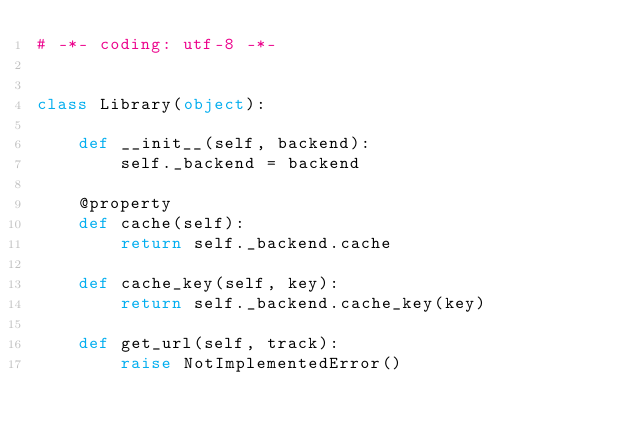Convert code to text. <code><loc_0><loc_0><loc_500><loc_500><_Python_># -*- coding: utf-8 -*-


class Library(object):

    def __init__(self, backend):
        self._backend = backend

    @property
    def cache(self):
        return self._backend.cache

    def cache_key(self, key):
        return self._backend.cache_key(key)

    def get_url(self, track):
        raise NotImplementedError()
</code> 